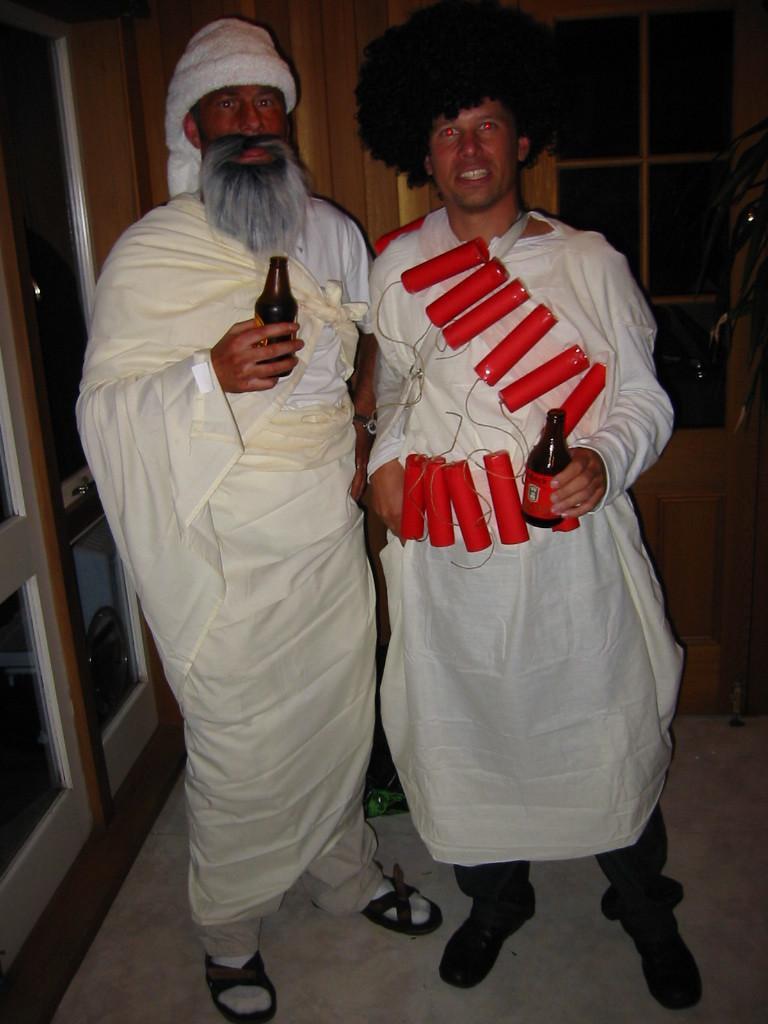Please provide a concise description of this image. In this image we can see there are two people standing together holding bottles in hand, in which one of them is wearing something on body. 